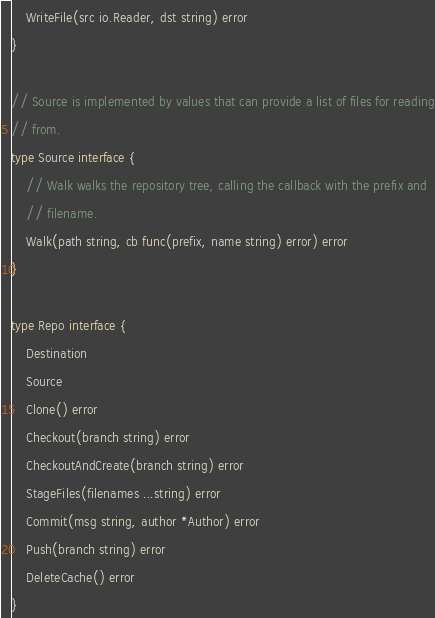<code> <loc_0><loc_0><loc_500><loc_500><_Go_>	WriteFile(src io.Reader, dst string) error
}

// Source is implemented by values that can provide a list of files for reading
// from.
type Source interface {
	// Walk walks the repository tree, calling the callback with the prefix and
	// filename.
	Walk(path string, cb func(prefix, name string) error) error
}

type Repo interface {
	Destination
	Source
	Clone() error
	Checkout(branch string) error
	CheckoutAndCreate(branch string) error
	StageFiles(filenames ...string) error
	Commit(msg string, author *Author) error
	Push(branch string) error
	DeleteCache() error
}
</code> 